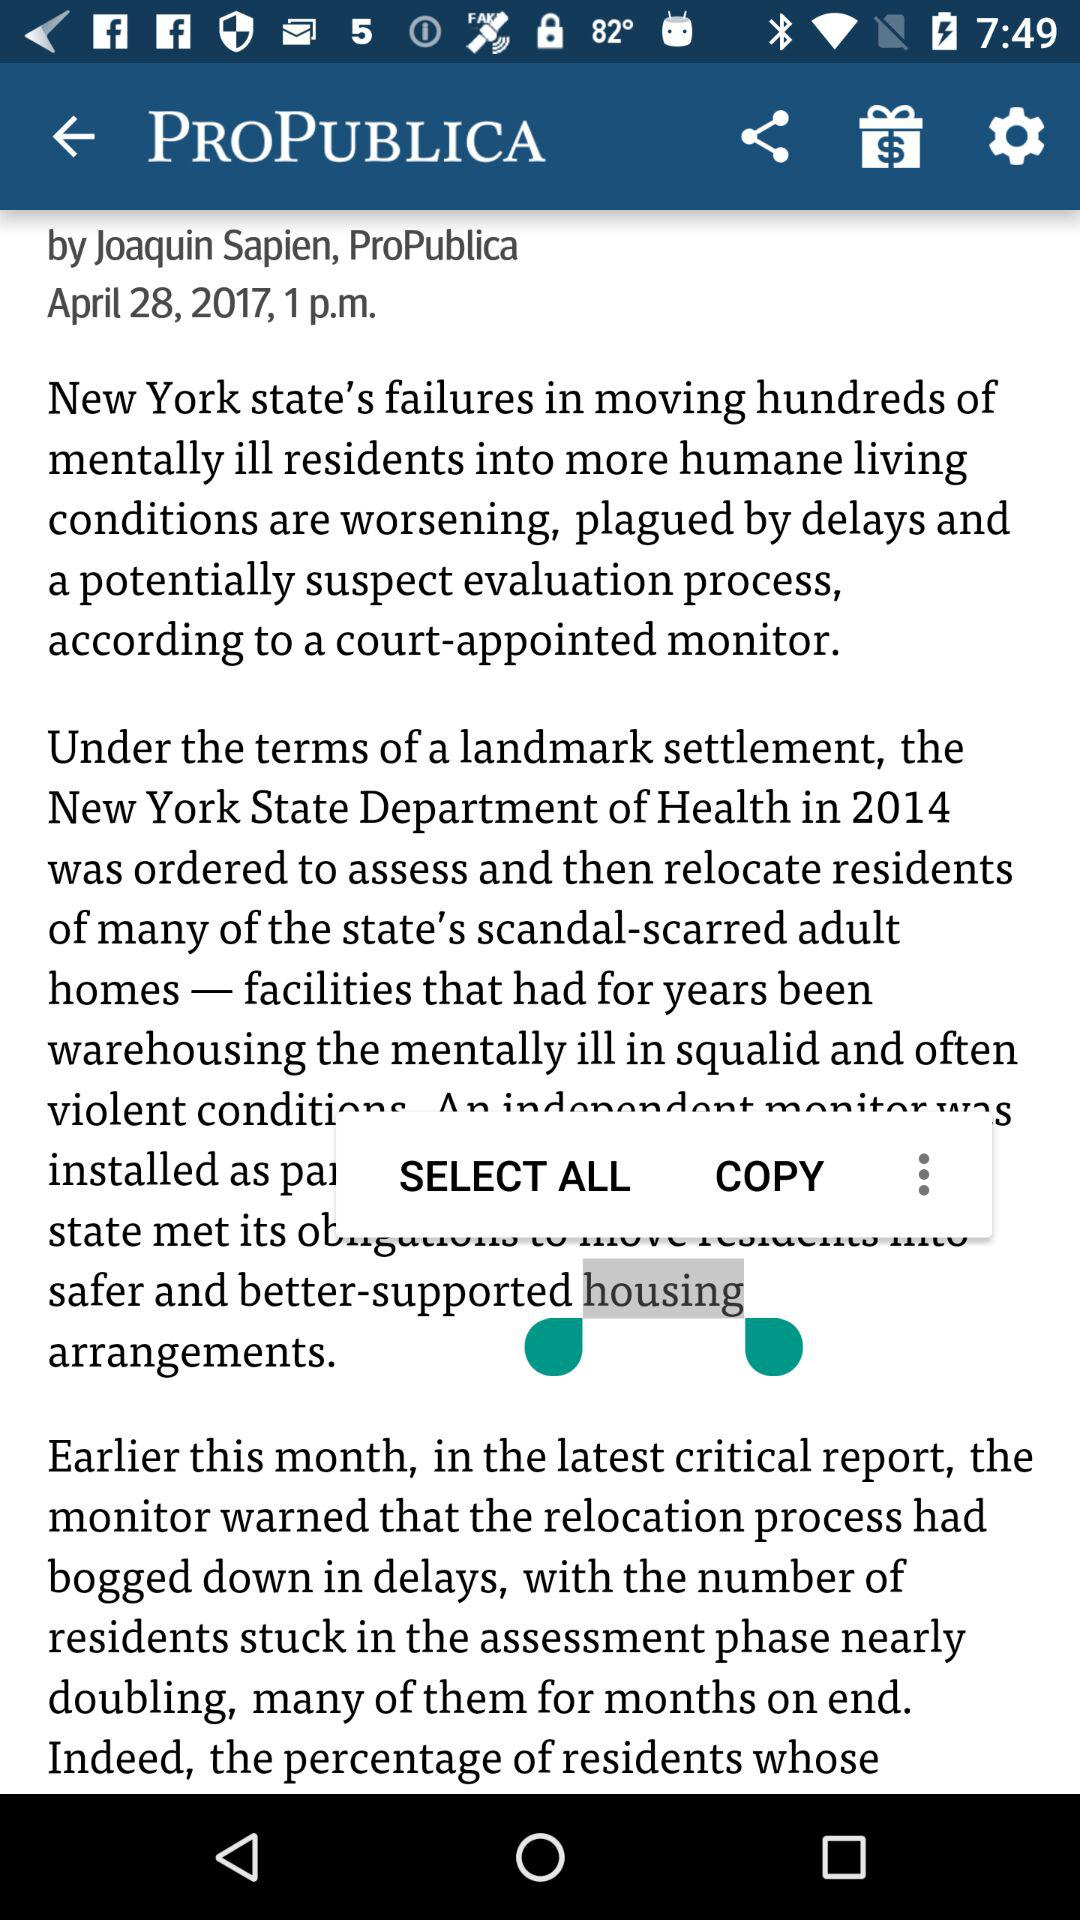Who is the writer? The writer is Joaquin Sapien. 